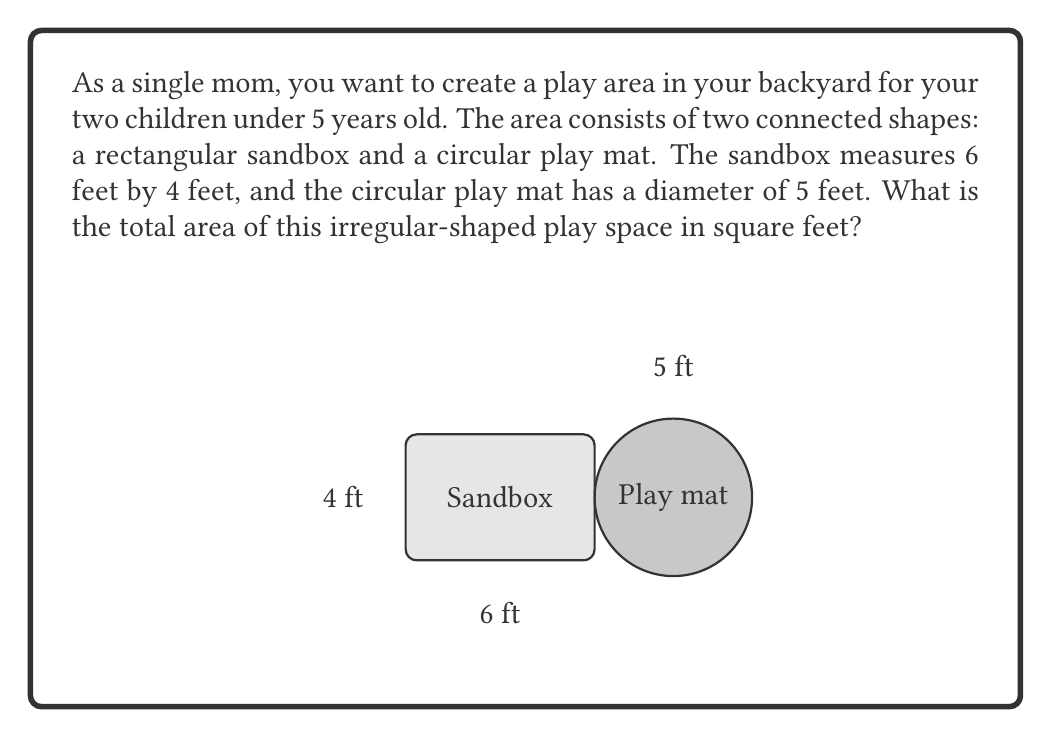Show me your answer to this math problem. To solve this problem, we need to calculate the areas of both shapes separately and then add them together:

1. Area of the rectangular sandbox:
   $$ A_{rectangle} = length \times width $$
   $$ A_{rectangle} = 6 \text{ ft} \times 4 \text{ ft} = 24 \text{ sq ft} $$

2. Area of the circular play mat:
   The formula for the area of a circle is $A = \pi r^2$, where $r$ is the radius.
   The diameter is 5 ft, so the radius is 2.5 ft.
   $$ A_{circle} = \pi r^2 = \pi (2.5 \text{ ft})^2 $$
   $$ A_{circle} = 6.25\pi \text{ sq ft} \approx 19.63 \text{ sq ft} $$

3. Total area of the play space:
   $$ A_{total} = A_{rectangle} + A_{circle} $$
   $$ A_{total} = 24 \text{ sq ft} + 19.63 \text{ sq ft} = 43.63 \text{ sq ft} $$

Therefore, the total area of the irregular-shaped play space is approximately 43.63 square feet.
Answer: 43.63 square feet 